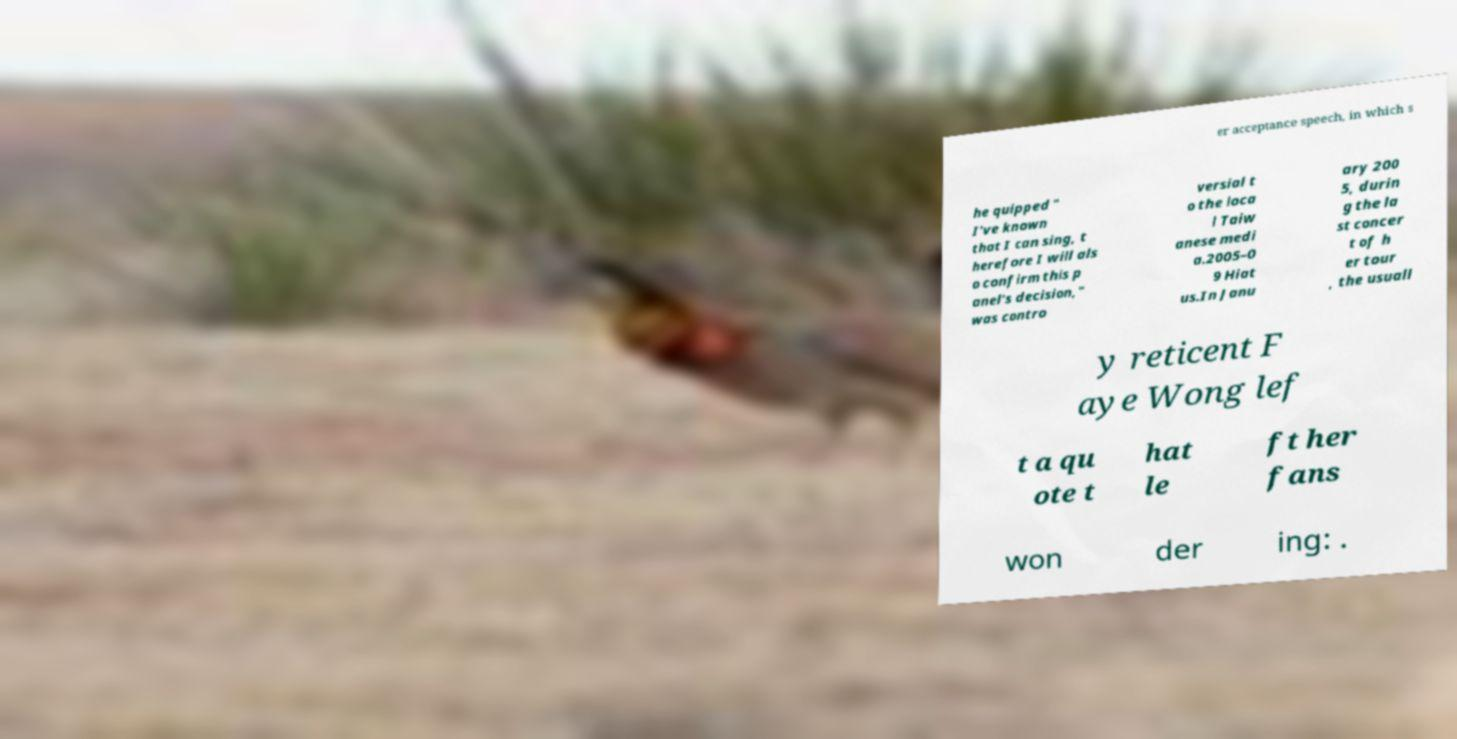For documentation purposes, I need the text within this image transcribed. Could you provide that? er acceptance speech, in which s he quipped " I've known that I can sing, t herefore I will als o confirm this p anel's decision," was contro versial t o the loca l Taiw anese medi a.2005–0 9 Hiat us.In Janu ary 200 5, durin g the la st concer t of h er tour , the usuall y reticent F aye Wong lef t a qu ote t hat le ft her fans won der ing: . 